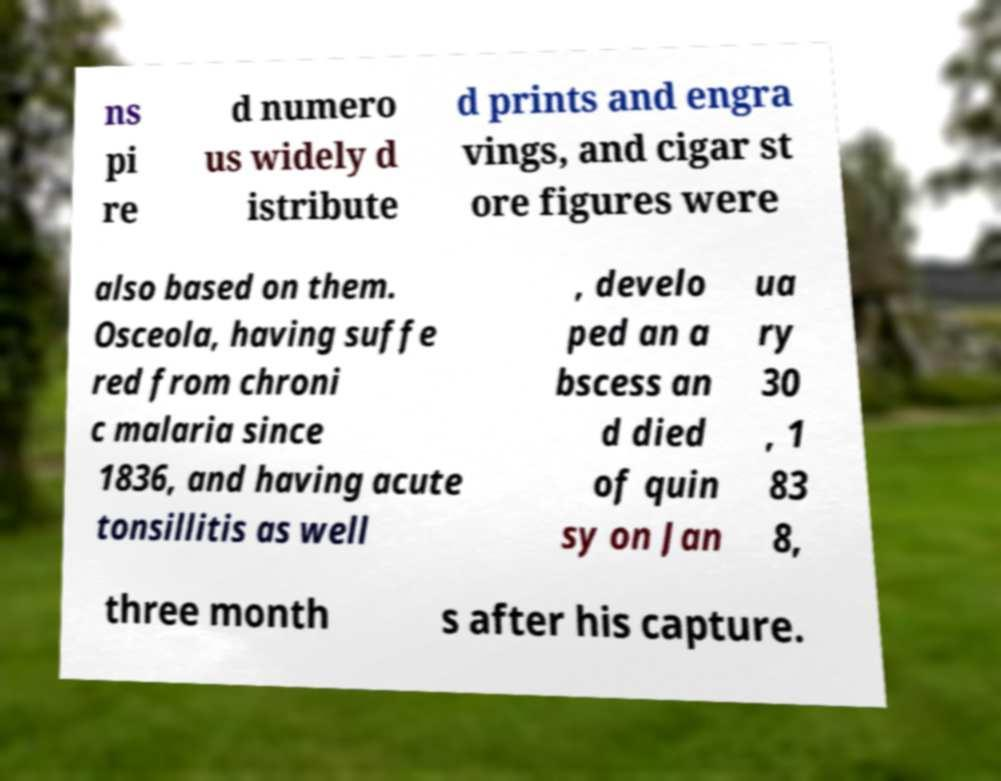There's text embedded in this image that I need extracted. Can you transcribe it verbatim? ns pi re d numero us widely d istribute d prints and engra vings, and cigar st ore figures were also based on them. Osceola, having suffe red from chroni c malaria since 1836, and having acute tonsillitis as well , develo ped an a bscess an d died of quin sy on Jan ua ry 30 , 1 83 8, three month s after his capture. 